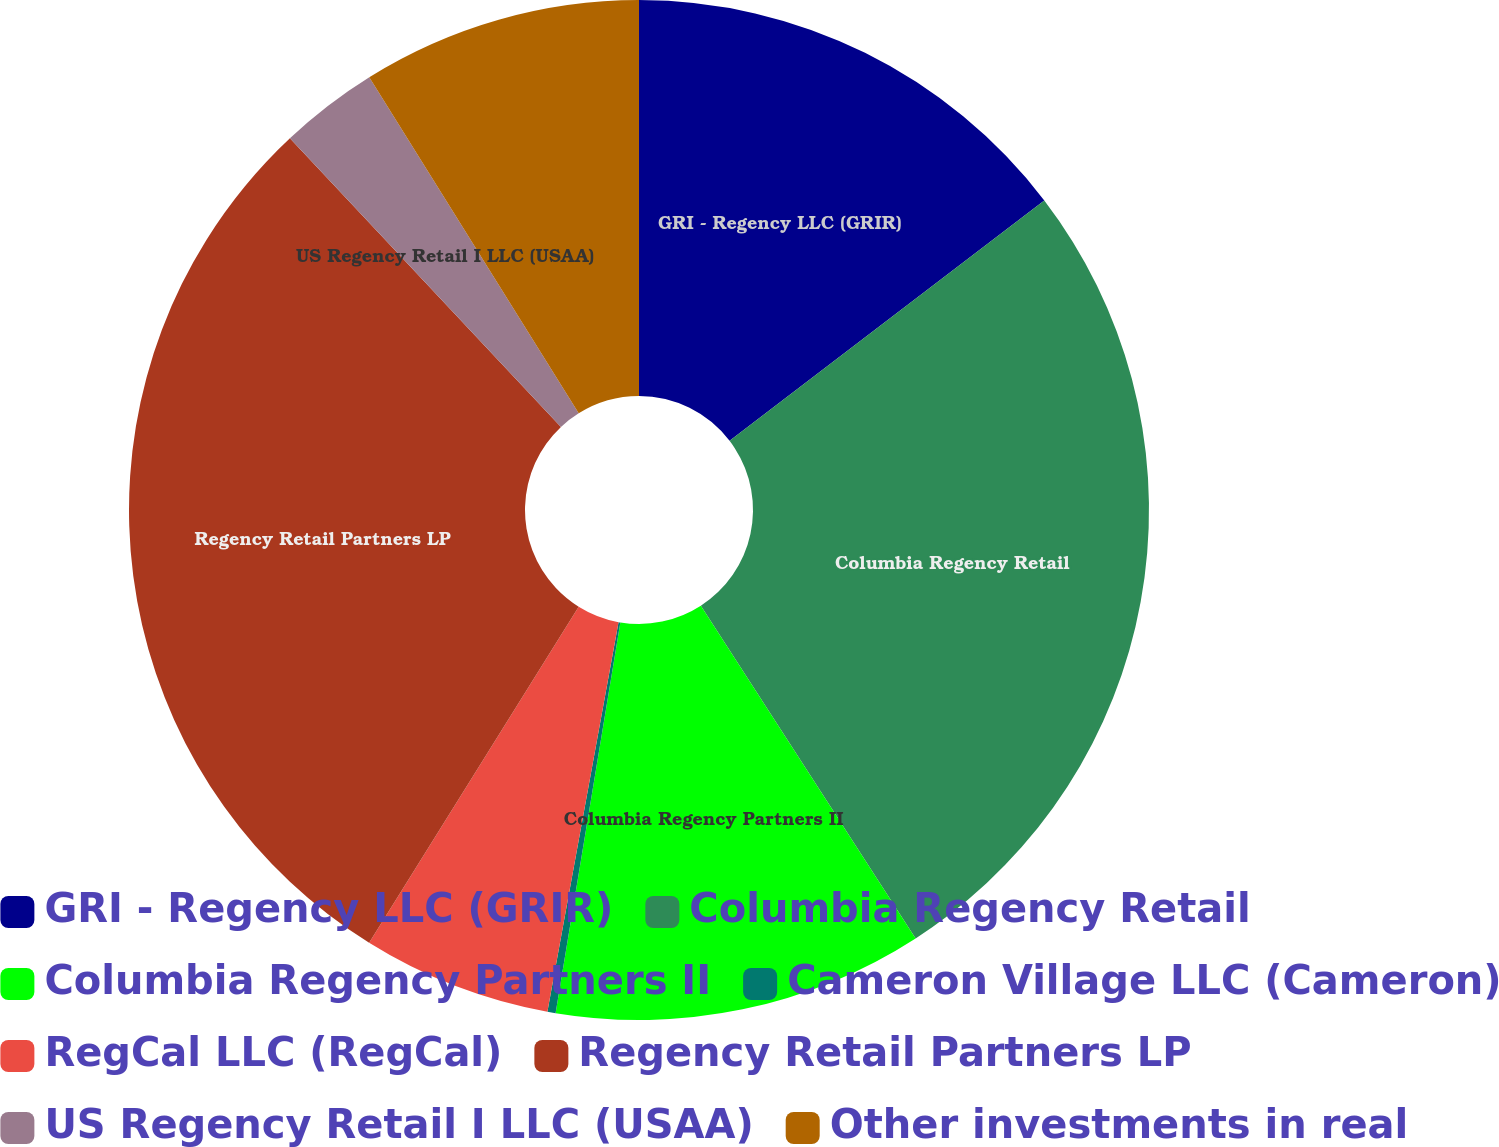Convert chart. <chart><loc_0><loc_0><loc_500><loc_500><pie_chart><fcel>GRI - Regency LLC (GRIR)<fcel>Columbia Regency Retail<fcel>Columbia Regency Partners II<fcel>Cameron Village LLC (Cameron)<fcel>RegCal LLC (RegCal)<fcel>Regency Retail Partners LP<fcel>US Regency Retail I LLC (USAA)<fcel>Other investments in real<nl><fcel>14.62%<fcel>26.26%<fcel>11.74%<fcel>0.26%<fcel>6.0%<fcel>29.13%<fcel>3.13%<fcel>8.87%<nl></chart> 